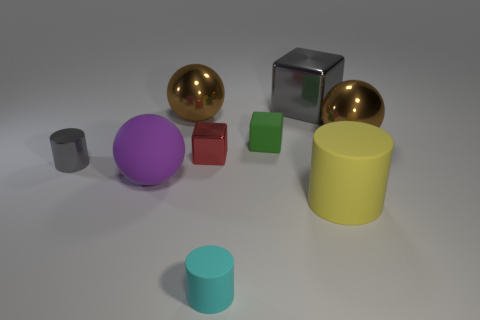Subtract all yellow blocks. How many brown spheres are left? 2 Subtract all small cubes. How many cubes are left? 1 Subtract 1 balls. How many balls are left? 2 Add 1 big rubber cylinders. How many objects exist? 10 Subtract all brown cubes. Subtract all green balls. How many cubes are left? 3 Add 6 tiny red blocks. How many tiny red blocks exist? 7 Subtract 0 purple cubes. How many objects are left? 9 Subtract all spheres. How many objects are left? 6 Subtract all cyan cylinders. Subtract all red blocks. How many objects are left? 7 Add 9 small cyan things. How many small cyan things are left? 10 